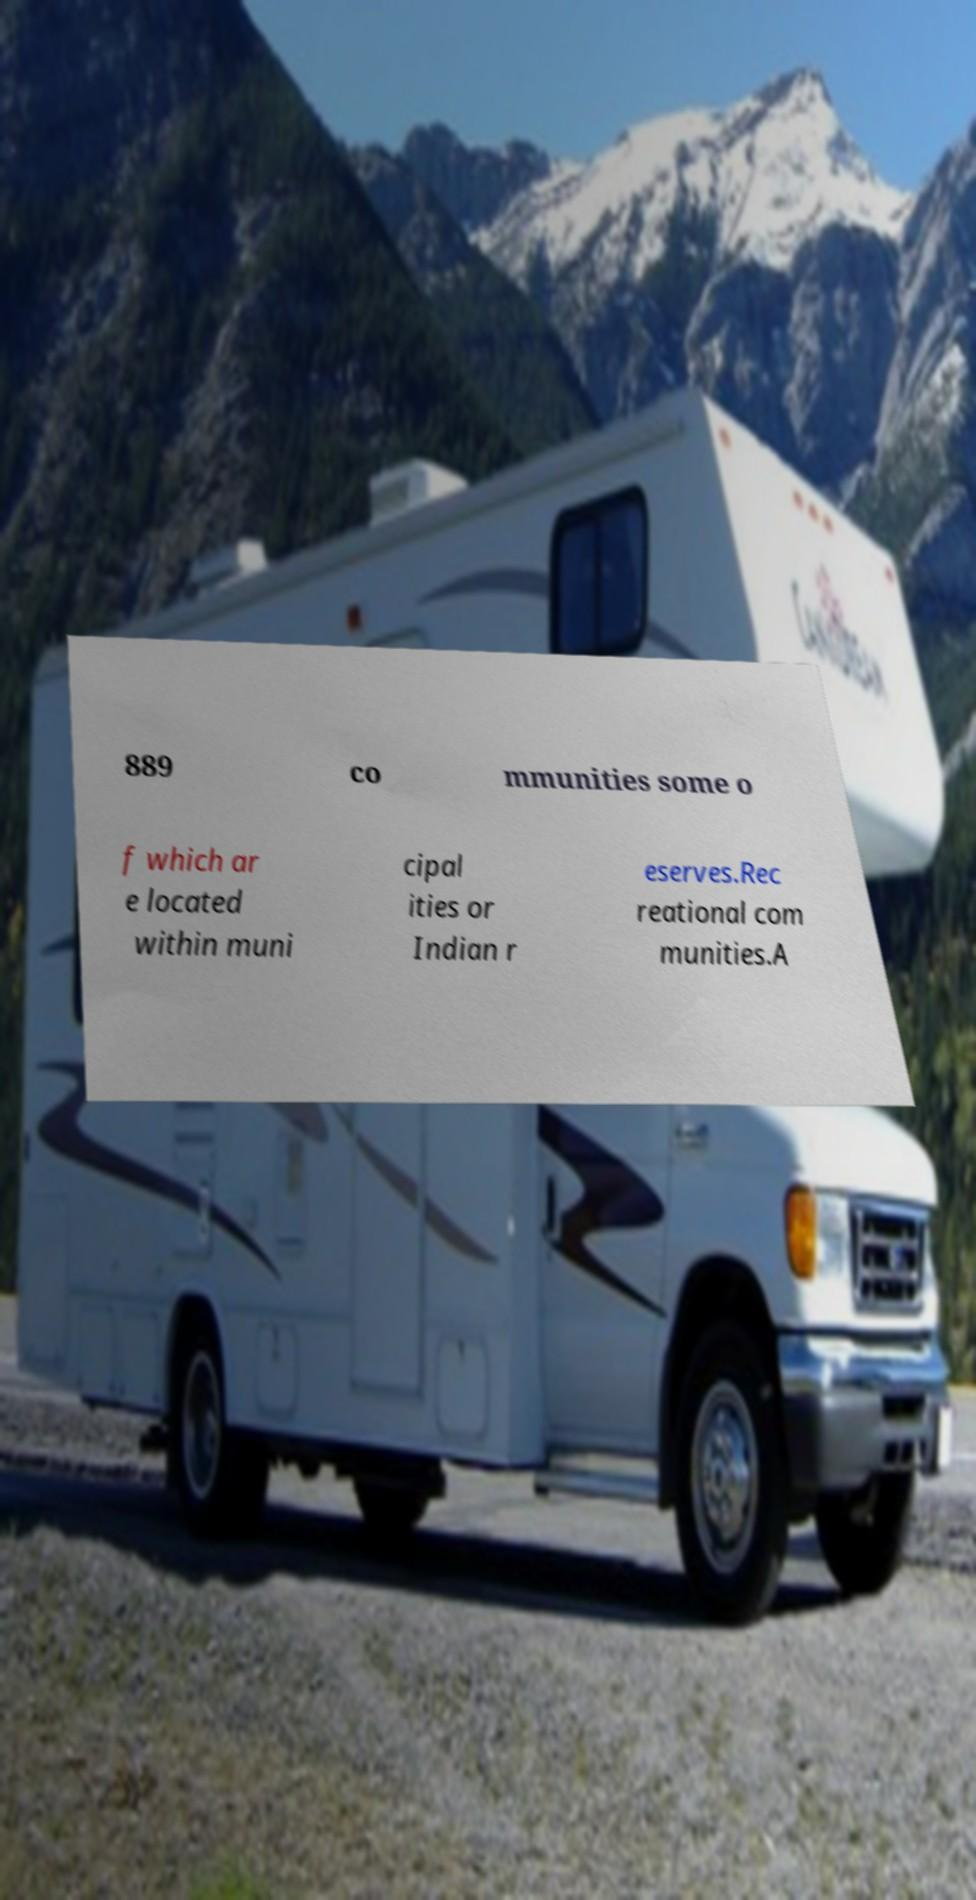I need the written content from this picture converted into text. Can you do that? 889 co mmunities some o f which ar e located within muni cipal ities or Indian r eserves.Rec reational com munities.A 